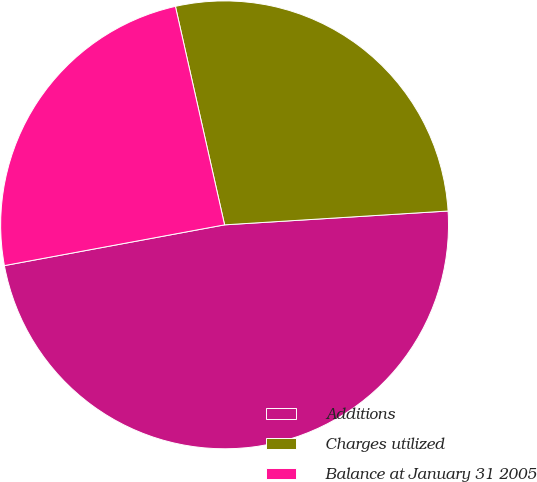Convert chart. <chart><loc_0><loc_0><loc_500><loc_500><pie_chart><fcel>Additions<fcel>Charges utilized<fcel>Balance at January 31 2005<nl><fcel>48.07%<fcel>27.54%<fcel>24.39%<nl></chart> 